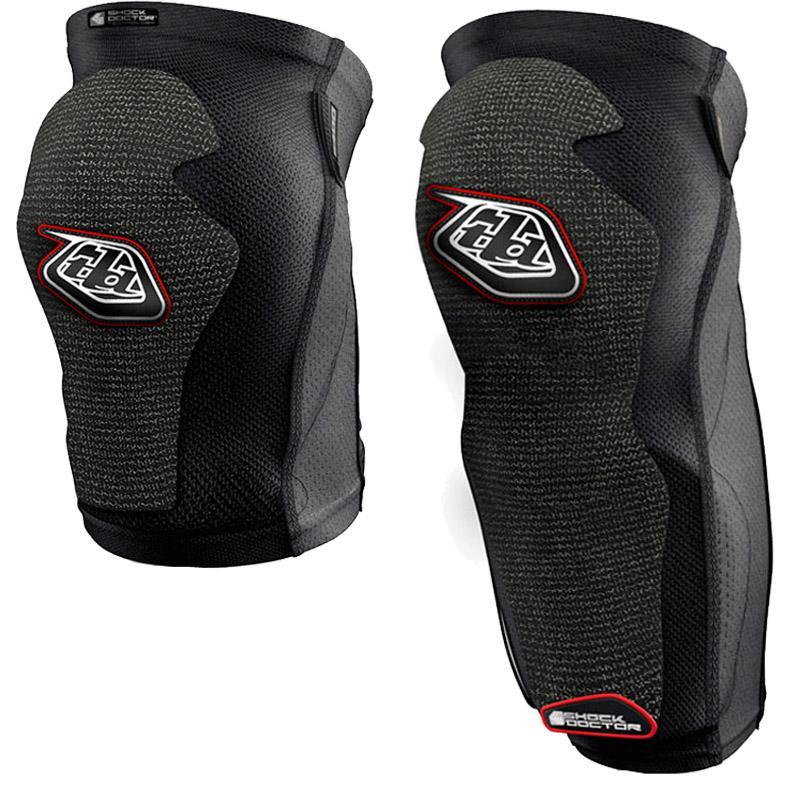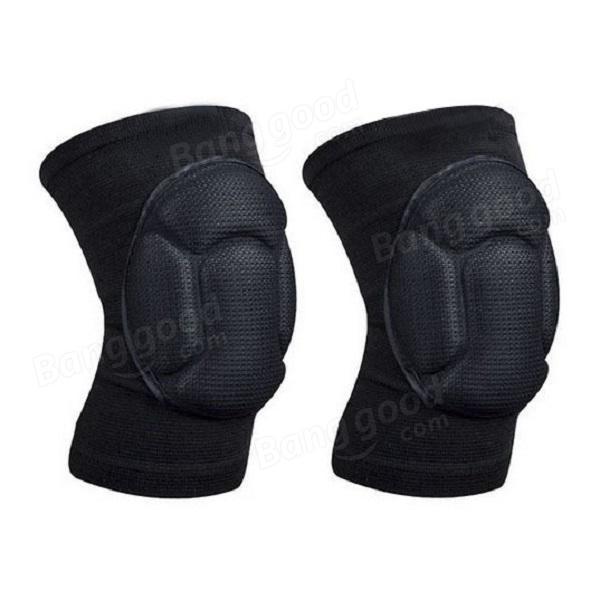The first image is the image on the left, the second image is the image on the right. Assess this claim about the two images: "The right image shows a right-turned pair of pads, and the left image shows front and back views of a pair of pads.". Correct or not? Answer yes or no. No. 